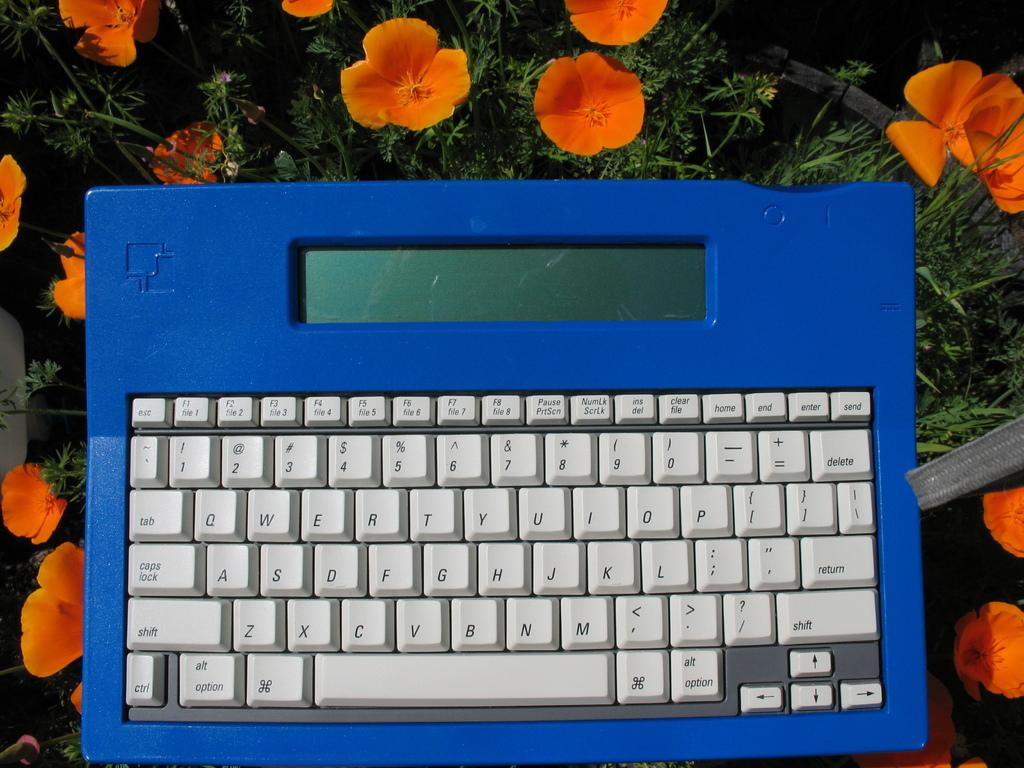What is the main object in the center of the image? There is a keyboard in the center of the image. What can be seen in the background of the image? There are flowers and plants in the background of the image. What type of lumber is being used to construct the keyboard in the image? There is no lumber present in the image, as the keyboard is an electronic device. 